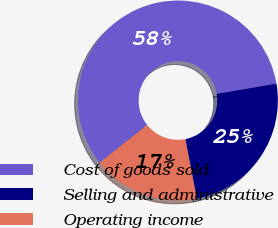<chart> <loc_0><loc_0><loc_500><loc_500><pie_chart><fcel>Cost of goods sold<fcel>Selling and administrative<fcel>Operating income<nl><fcel>57.98%<fcel>24.68%<fcel>17.34%<nl></chart> 